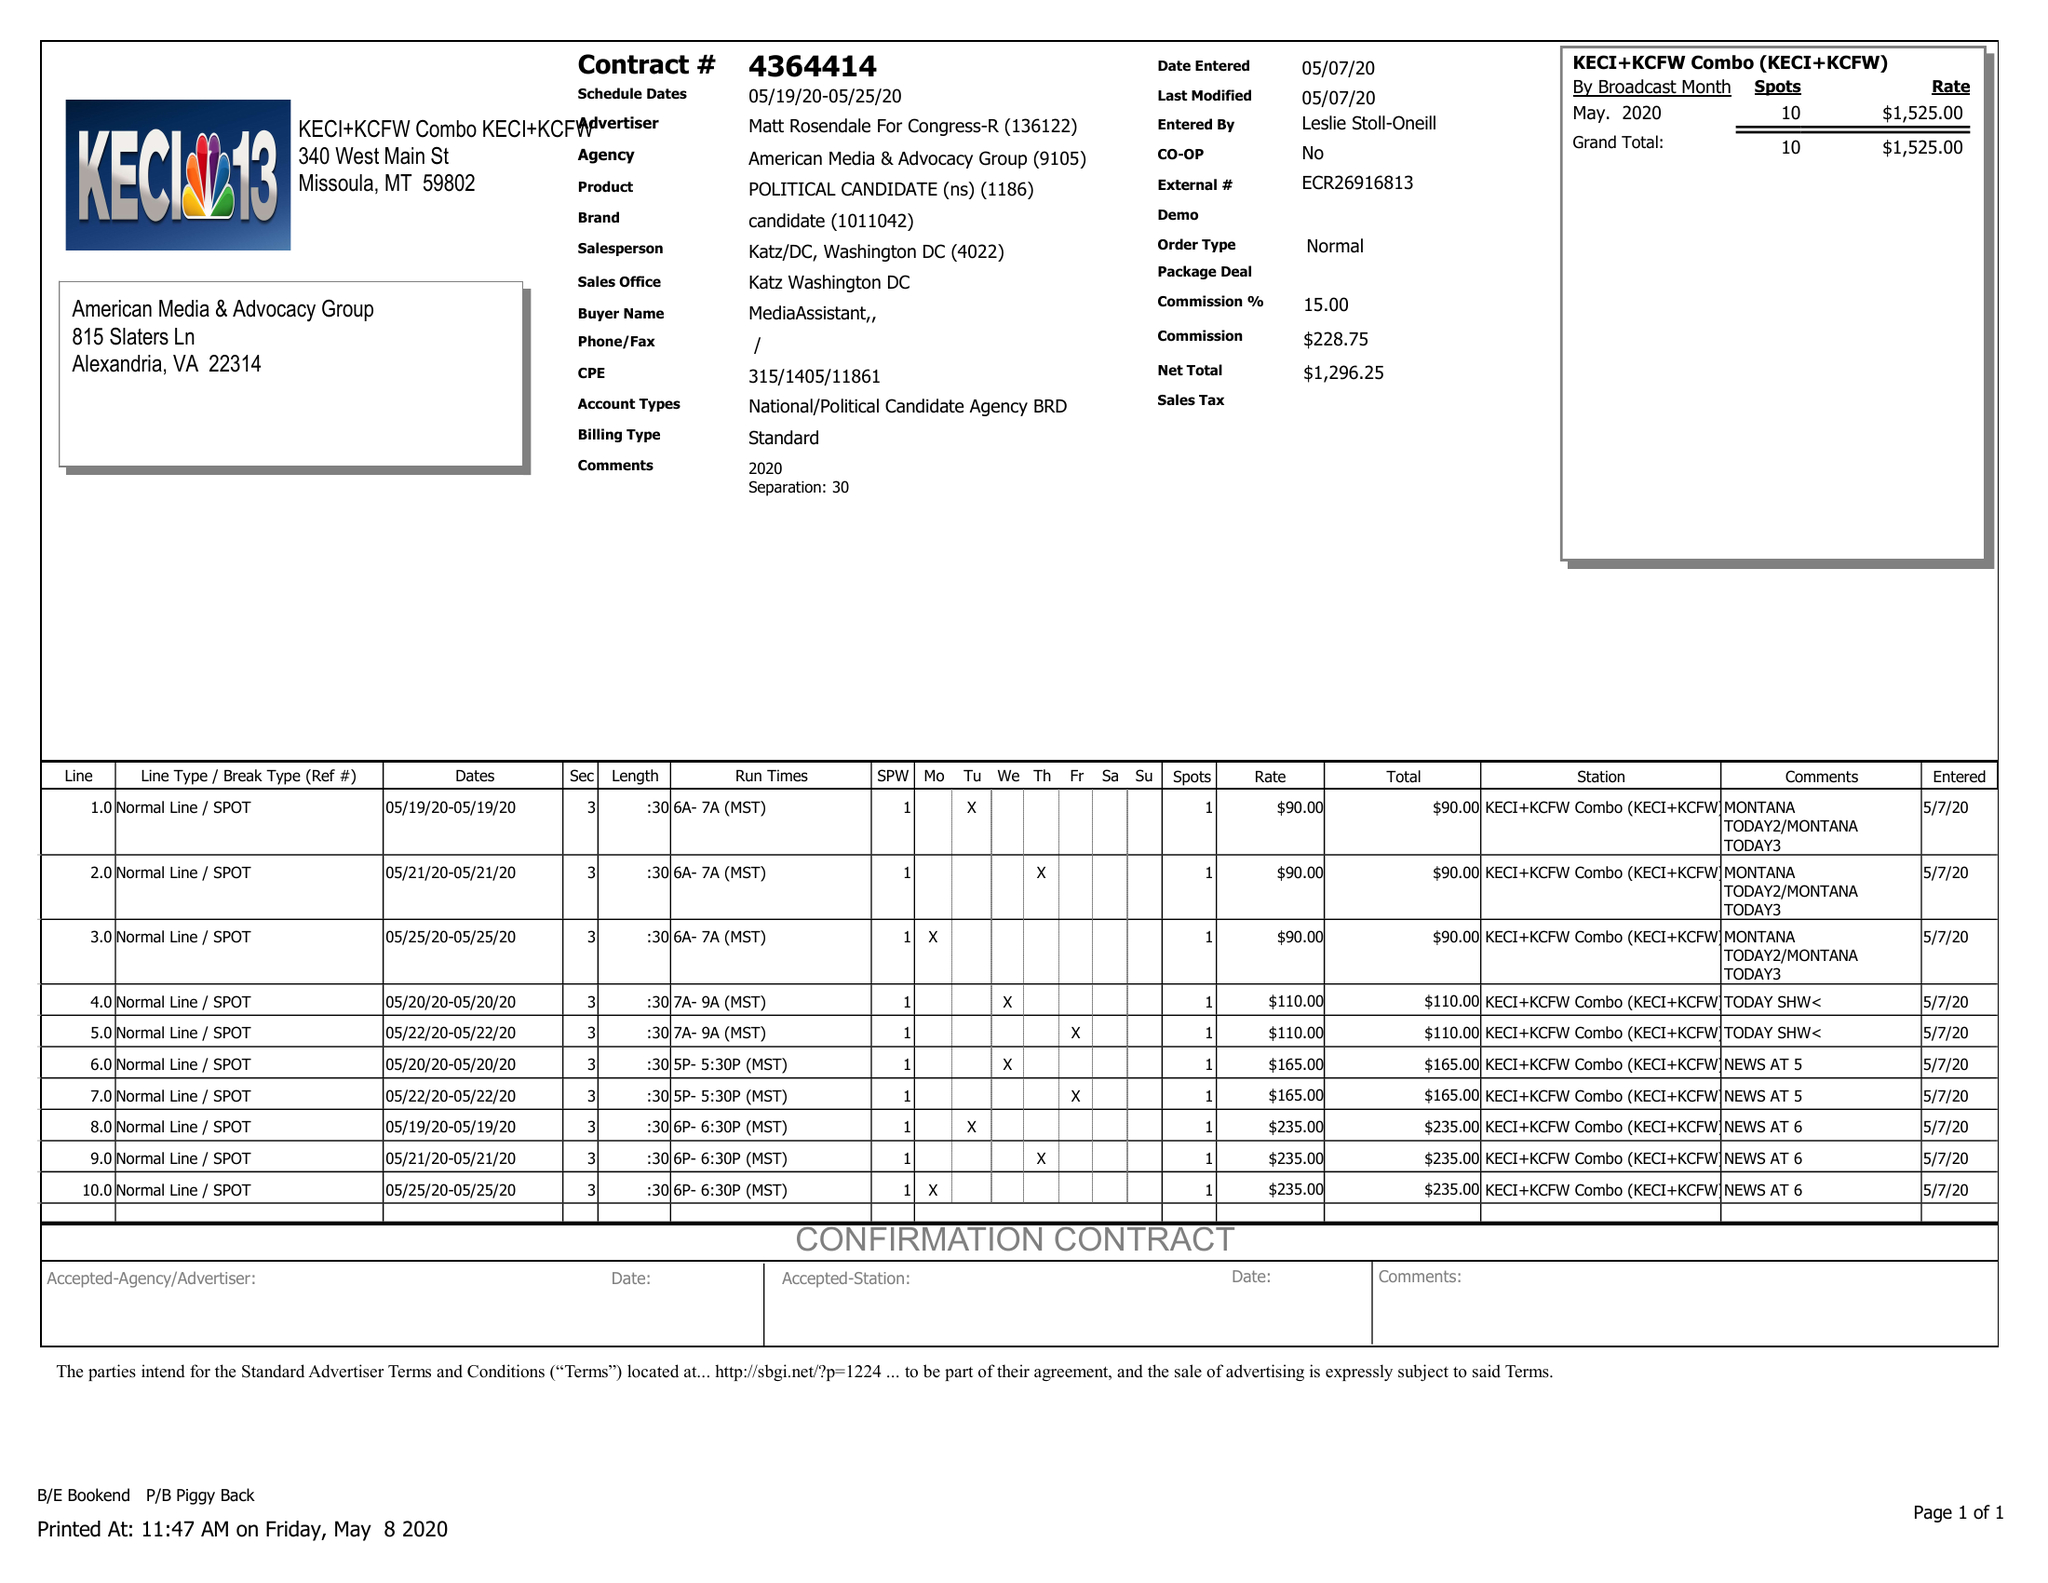What is the value for the flight_from?
Answer the question using a single word or phrase. 05/19/20 